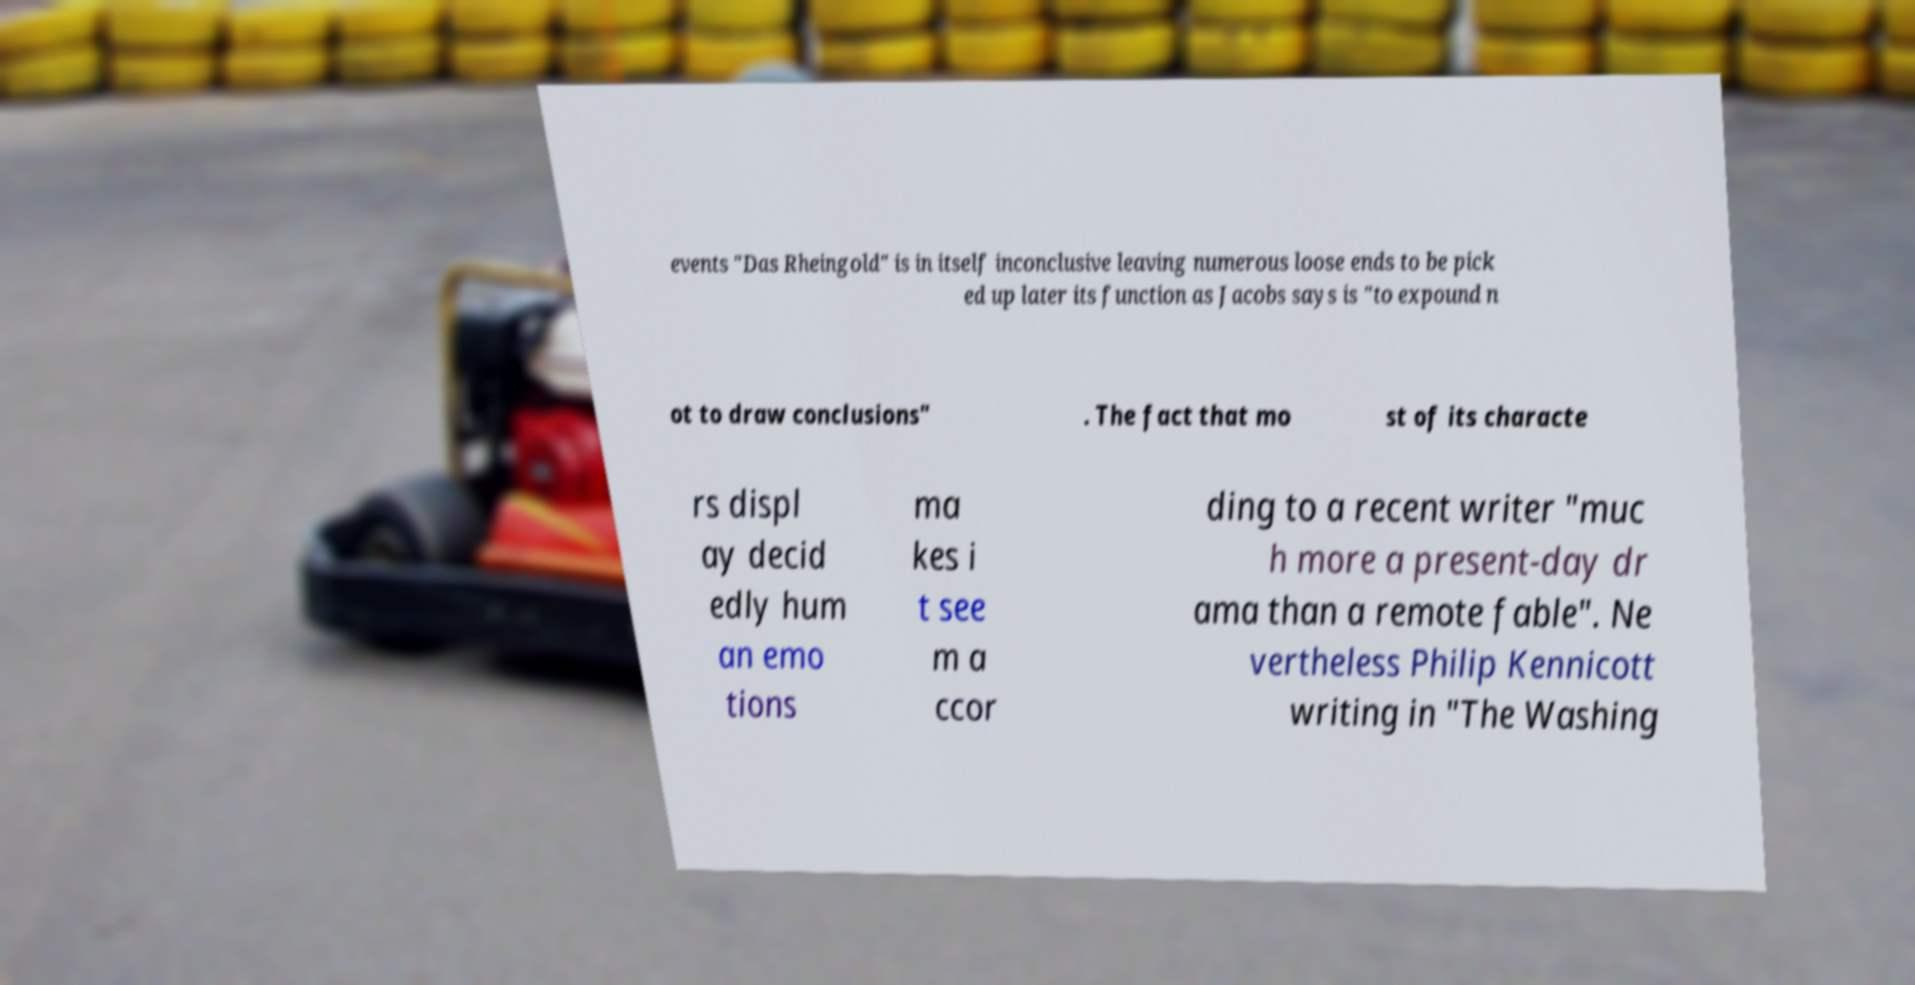I need the written content from this picture converted into text. Can you do that? events "Das Rheingold" is in itself inconclusive leaving numerous loose ends to be pick ed up later its function as Jacobs says is "to expound n ot to draw conclusions" . The fact that mo st of its characte rs displ ay decid edly hum an emo tions ma kes i t see m a ccor ding to a recent writer "muc h more a present-day dr ama than a remote fable". Ne vertheless Philip Kennicott writing in "The Washing 